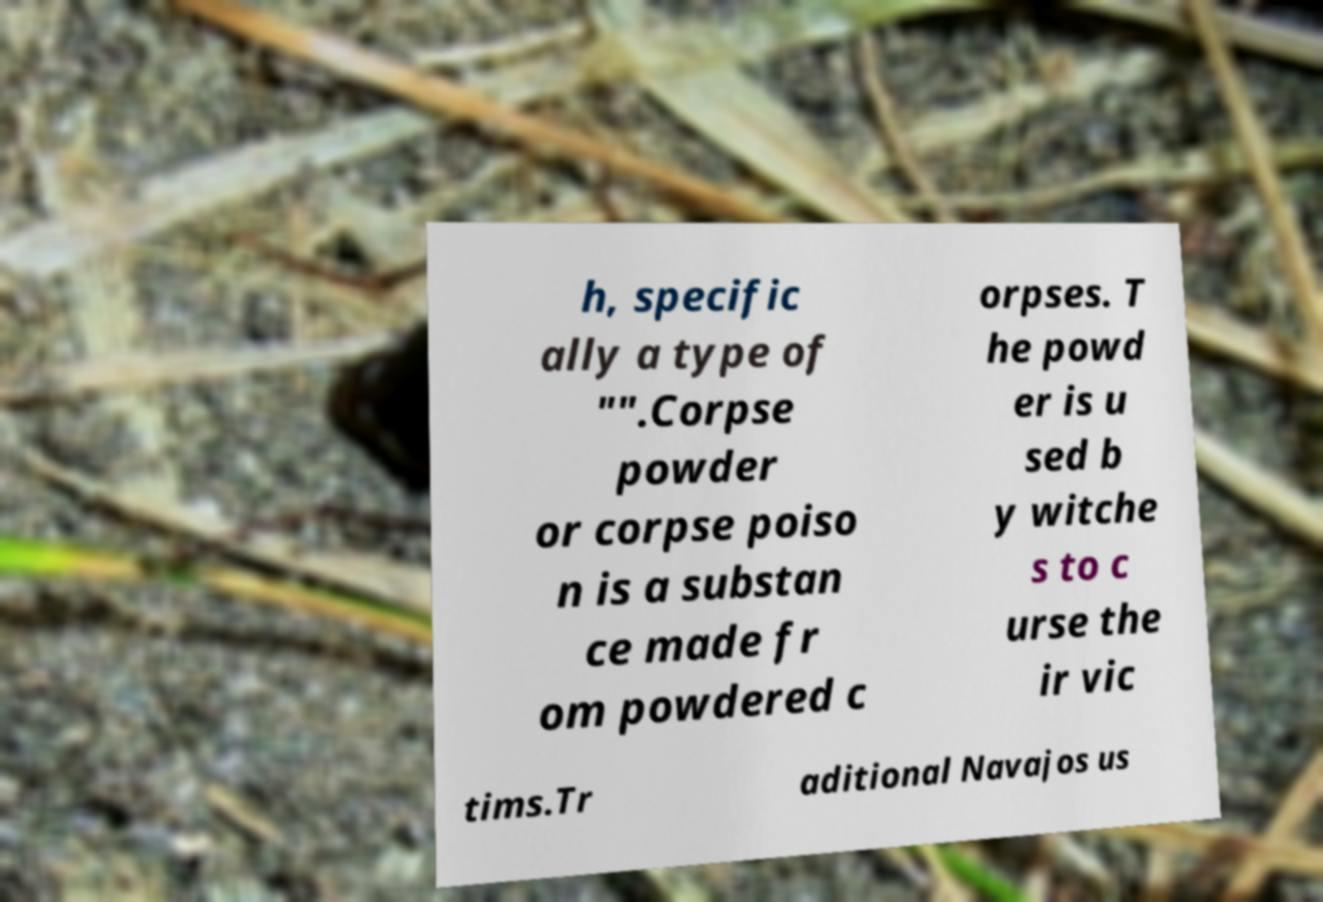Please read and relay the text visible in this image. What does it say? h, specific ally a type of "".Corpse powder or corpse poiso n is a substan ce made fr om powdered c orpses. T he powd er is u sed b y witche s to c urse the ir vic tims.Tr aditional Navajos us 